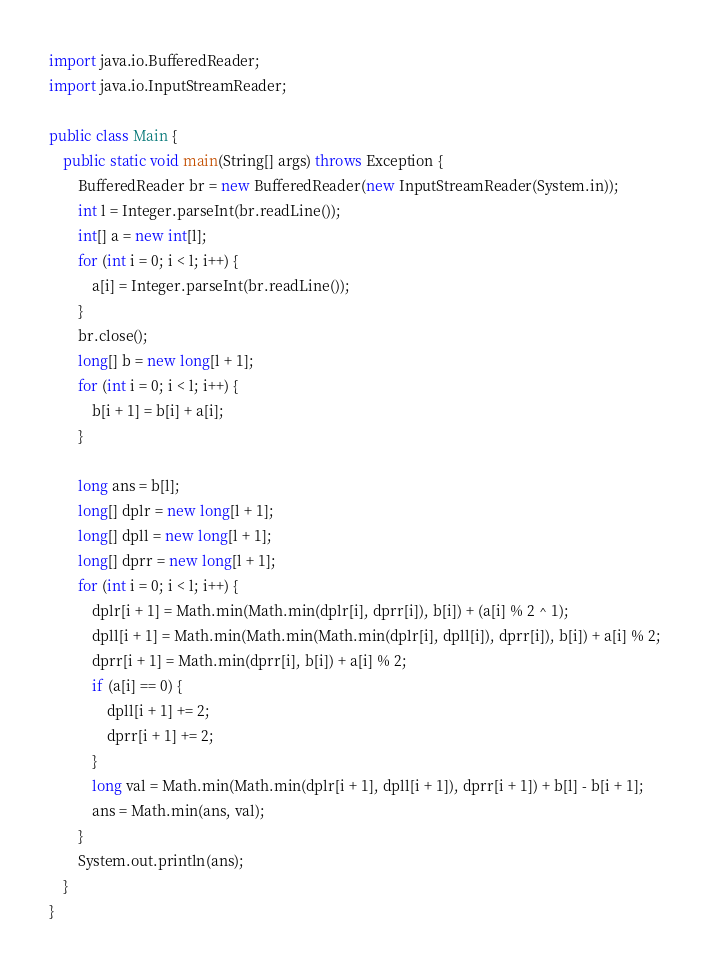Convert code to text. <code><loc_0><loc_0><loc_500><loc_500><_Java_>import java.io.BufferedReader;
import java.io.InputStreamReader;

public class Main {
	public static void main(String[] args) throws Exception {
		BufferedReader br = new BufferedReader(new InputStreamReader(System.in));
		int l = Integer.parseInt(br.readLine());
		int[] a = new int[l];
		for (int i = 0; i < l; i++) {
			a[i] = Integer.parseInt(br.readLine());
		}
		br.close();
		long[] b = new long[l + 1];
		for (int i = 0; i < l; i++) {
			b[i + 1] = b[i] + a[i];
		}

		long ans = b[l];
		long[] dplr = new long[l + 1];
		long[] dpll = new long[l + 1];
		long[] dprr = new long[l + 1];
		for (int i = 0; i < l; i++) {
			dplr[i + 1] = Math.min(Math.min(dplr[i], dprr[i]), b[i]) + (a[i] % 2 ^ 1);
			dpll[i + 1] = Math.min(Math.min(Math.min(dplr[i], dpll[i]), dprr[i]), b[i]) + a[i] % 2;
			dprr[i + 1] = Math.min(dprr[i], b[i]) + a[i] % 2;
			if (a[i] == 0) {
				dpll[i + 1] += 2;
				dprr[i + 1] += 2;
			}
			long val = Math.min(Math.min(dplr[i + 1], dpll[i + 1]), dprr[i + 1]) + b[l] - b[i + 1];
			ans = Math.min(ans, val);
		}
		System.out.println(ans);
	}
}
</code> 